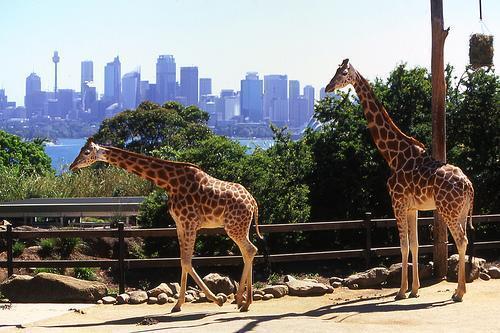How many giraffes are In the image?
Give a very brief answer. 2. How many feet does the giraffe have?
Give a very brief answer. 4. How many giraffe are pictured?
Give a very brief answer. 2. How many giraffes are visible?
Give a very brief answer. 2. 